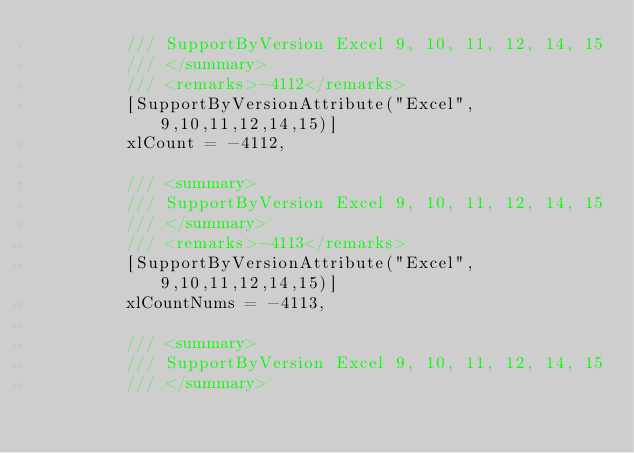<code> <loc_0><loc_0><loc_500><loc_500><_C#_>		 /// SupportByVersion Excel 9, 10, 11, 12, 14, 15
		 /// </summary>
		 /// <remarks>-4112</remarks>
		 [SupportByVersionAttribute("Excel", 9,10,11,12,14,15)]
		 xlCount = -4112,

		 /// <summary>
		 /// SupportByVersion Excel 9, 10, 11, 12, 14, 15
		 /// </summary>
		 /// <remarks>-4113</remarks>
		 [SupportByVersionAttribute("Excel", 9,10,11,12,14,15)]
		 xlCountNums = -4113,

		 /// <summary>
		 /// SupportByVersion Excel 9, 10, 11, 12, 14, 15
		 /// </summary></code> 